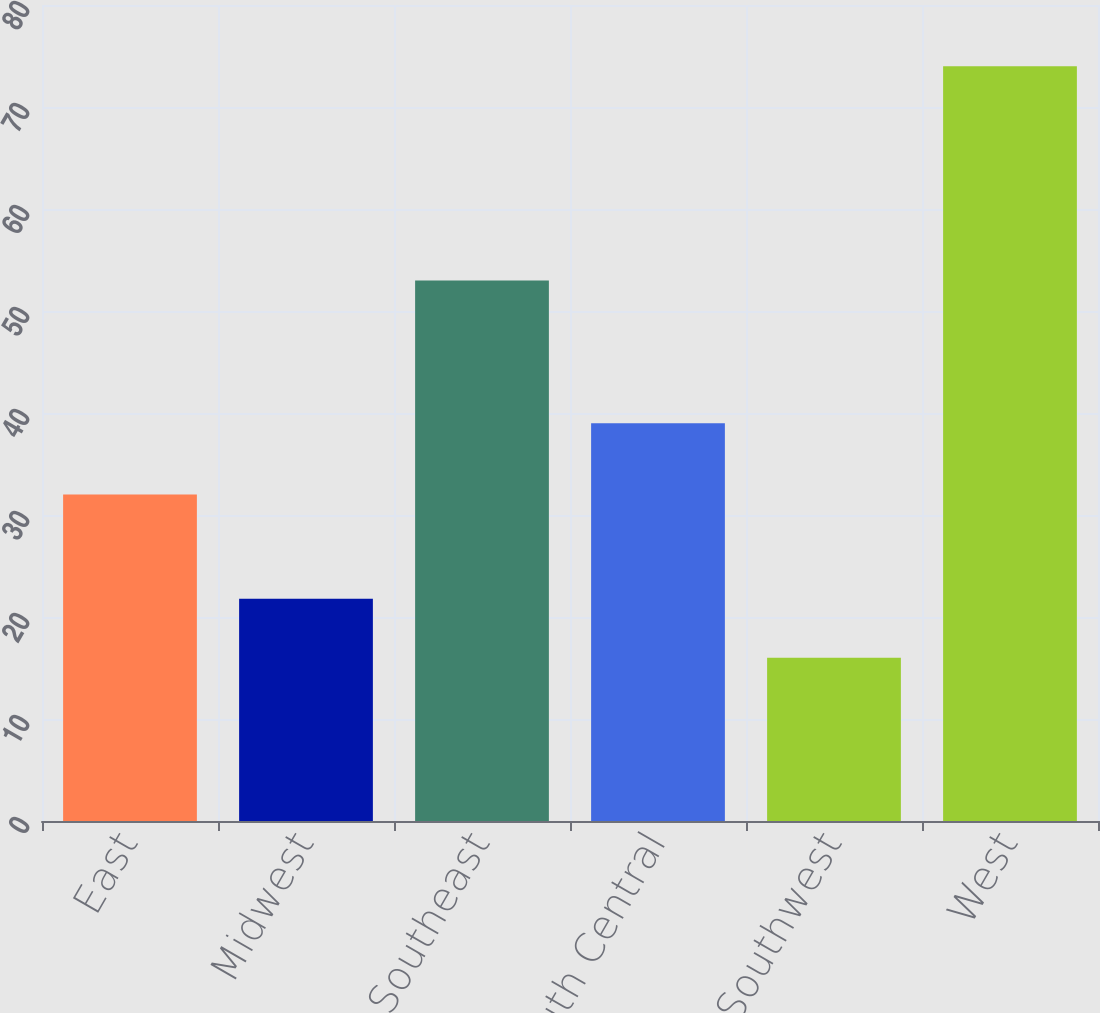<chart> <loc_0><loc_0><loc_500><loc_500><bar_chart><fcel>East<fcel>Midwest<fcel>Southeast<fcel>South Central<fcel>Southwest<fcel>West<nl><fcel>32<fcel>21.8<fcel>53<fcel>39<fcel>16<fcel>74<nl></chart> 